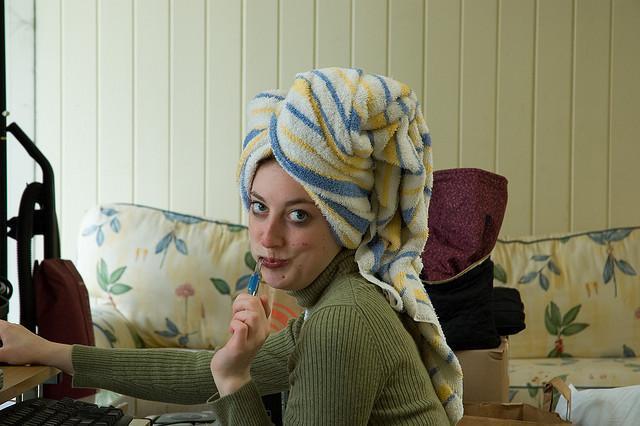How many people are in the picture?
Give a very brief answer. 1. How many televisions sets in the picture are turned on?
Give a very brief answer. 0. 